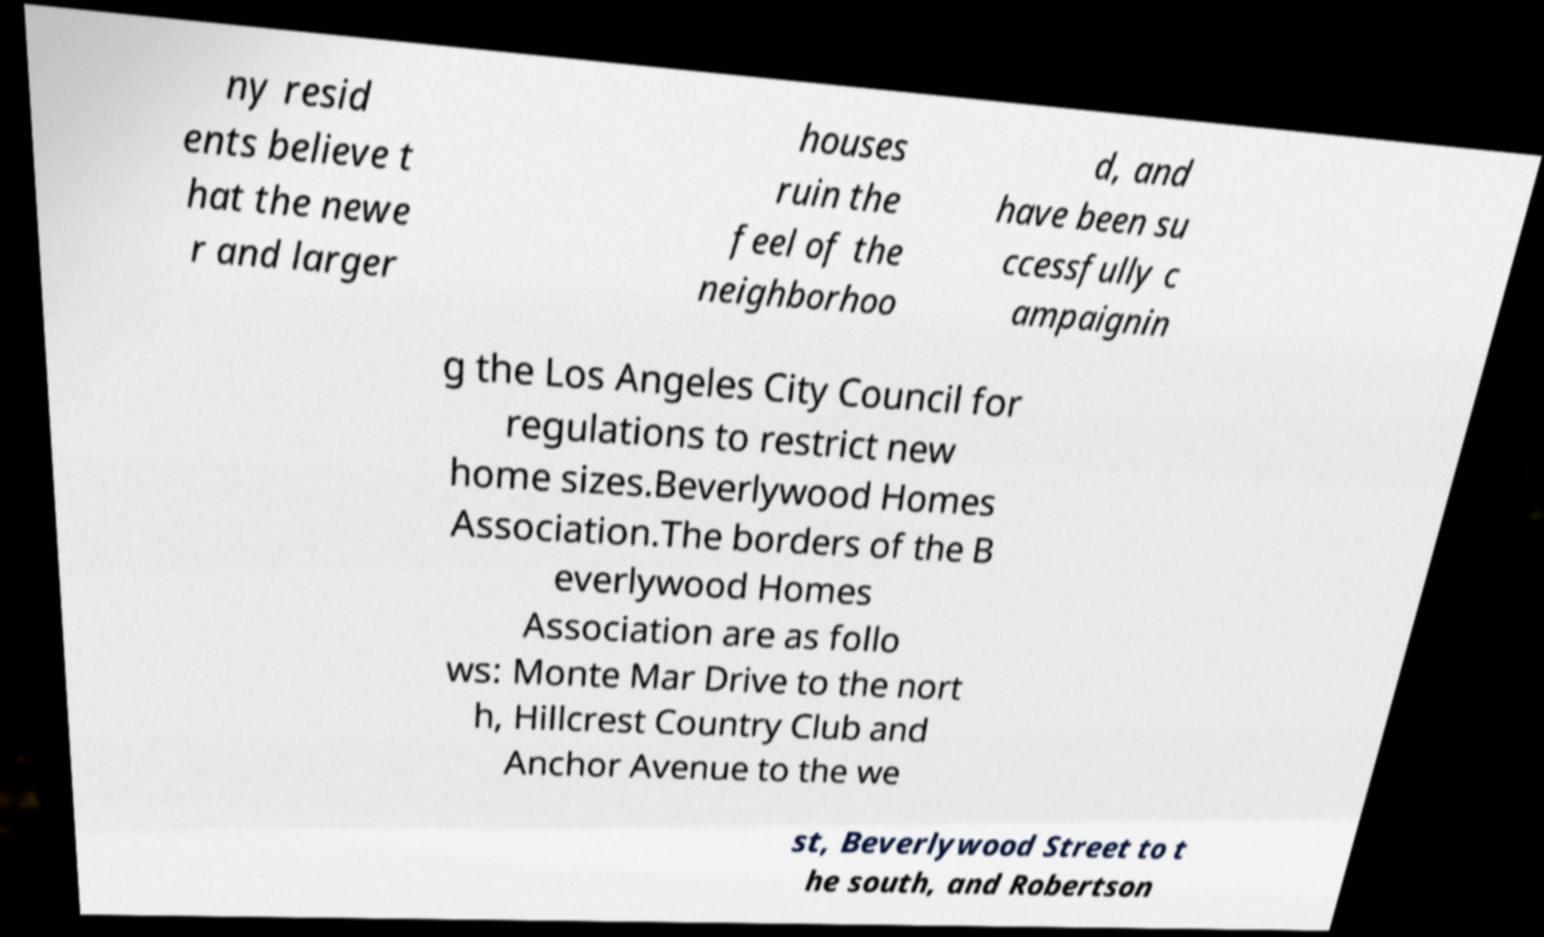Can you accurately transcribe the text from the provided image for me? ny resid ents believe t hat the newe r and larger houses ruin the feel of the neighborhoo d, and have been su ccessfully c ampaignin g the Los Angeles City Council for regulations to restrict new home sizes.Beverlywood Homes Association.The borders of the B everlywood Homes Association are as follo ws: Monte Mar Drive to the nort h, Hillcrest Country Club and Anchor Avenue to the we st, Beverlywood Street to t he south, and Robertson 